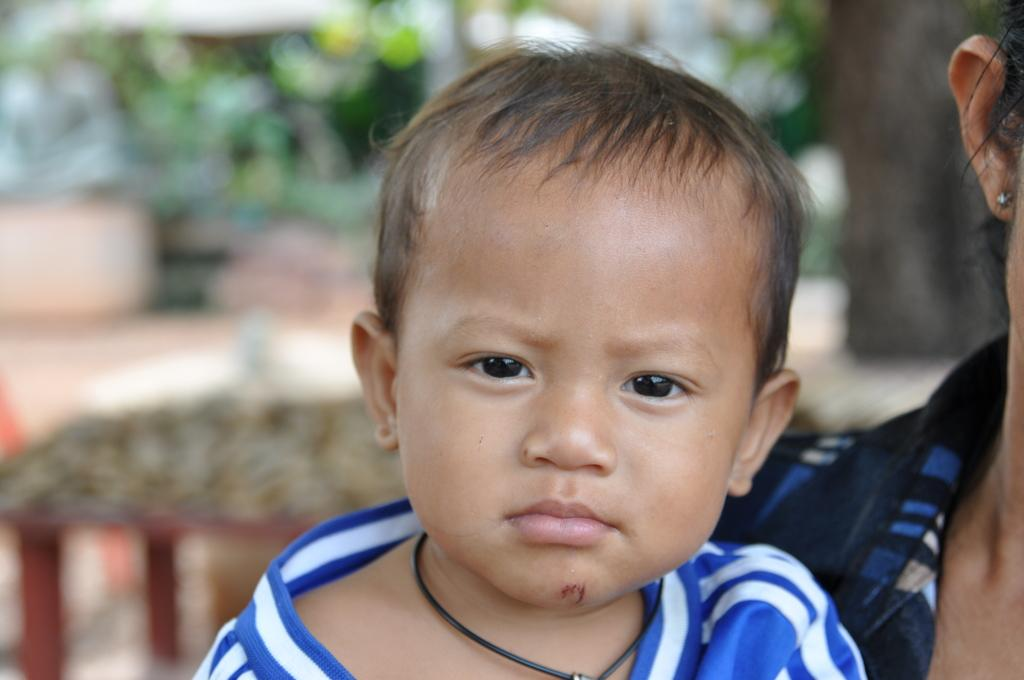What is the main subject of the image? There is a kid in the image. Can you describe another person in the image? Yes, there is a person in the image. How would you describe the background of the image? The background of the image is blurred. What type of cakes does the kid have a desire for in the image? There is no indication of cakes or any specific desires in the image. 